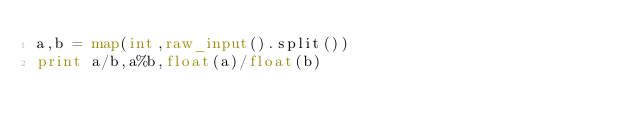Convert code to text. <code><loc_0><loc_0><loc_500><loc_500><_Python_>a,b = map(int,raw_input().split())
print a/b,a%b,float(a)/float(b)</code> 